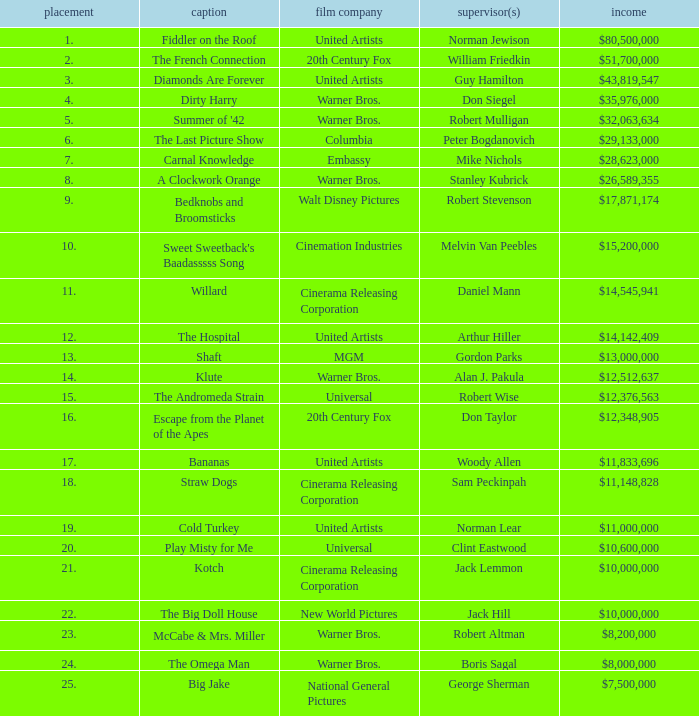What is the rank associated with $35,976,000 in gross? 4.0. 